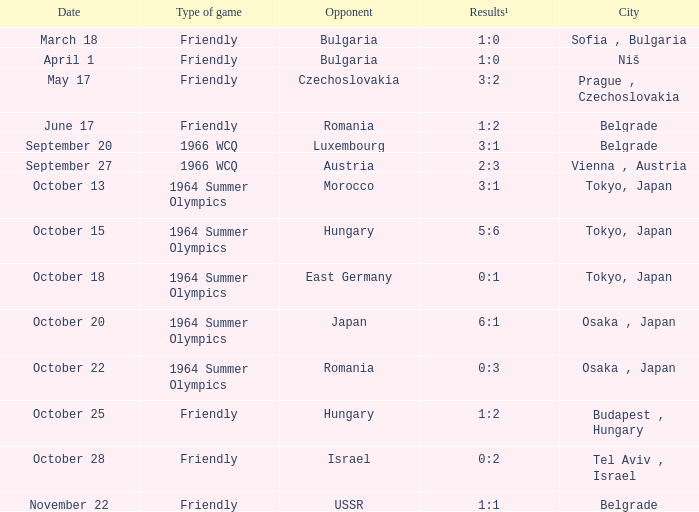What was the result for the 1964 summer olympics on october 18? 0:1. 